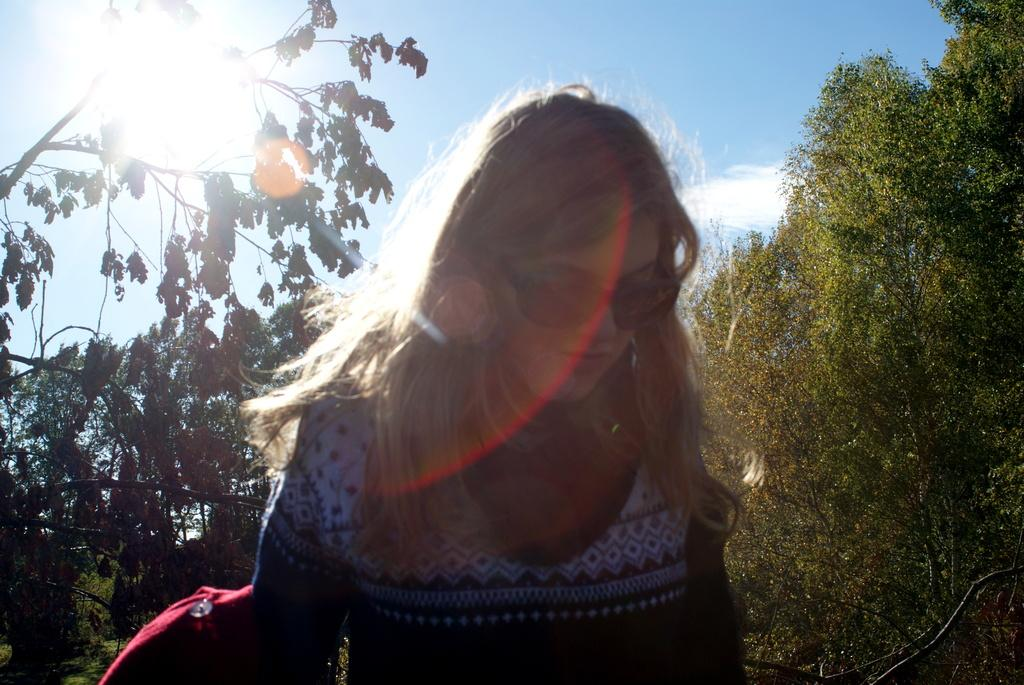Who is the main subject in the image? There is a woman standing in the center of the image. What can be seen on both sides of the woman? There are trees on both the right and left sides of the image. What is visible in the background of the image? The sky is visible in the background of the image. How many pigs are visible in the image? There are no pigs present in the image. 